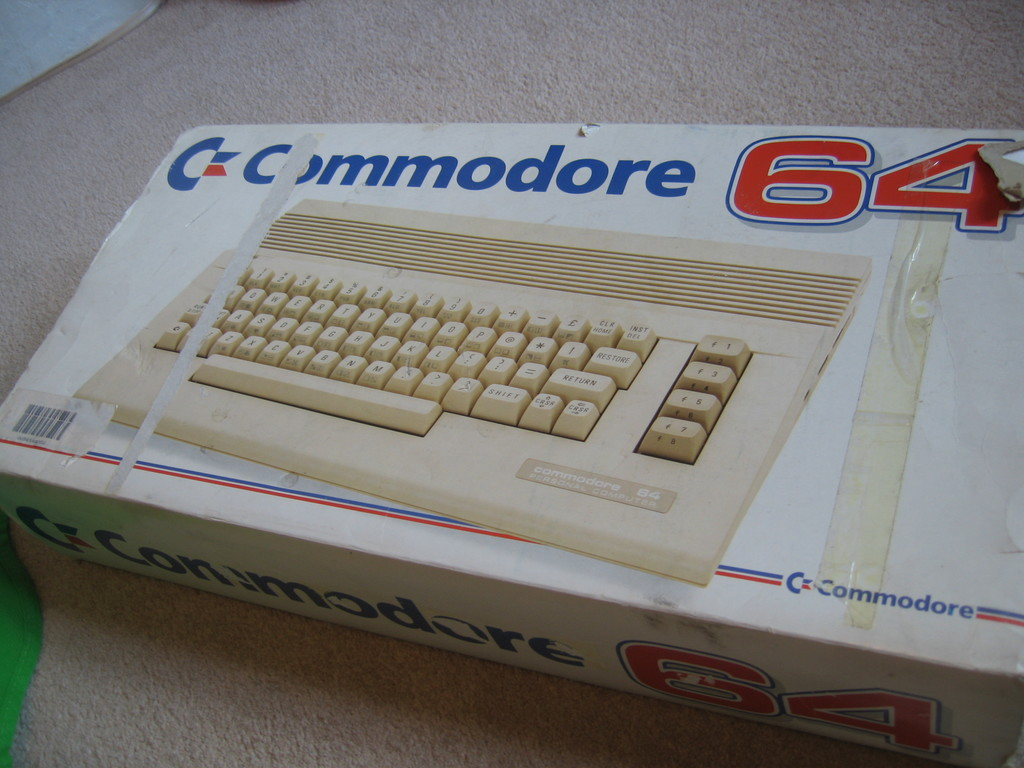What could be inferred about the owner of this item from its condition? The item's condition, with wear, tape, and creases on the box, suggests it has been well-used and possibly moved or stored multiple times. This wear indicates the owner may have held onto it for sentimental reasons or as a collector's item, hinting at a personal value placed on the computer beyond its functional use. 